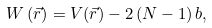<formula> <loc_0><loc_0><loc_500><loc_500>W \left ( \vec { r } \right ) = V ( \vec { r } ) - 2 \left ( N - 1 \right ) b ,</formula> 